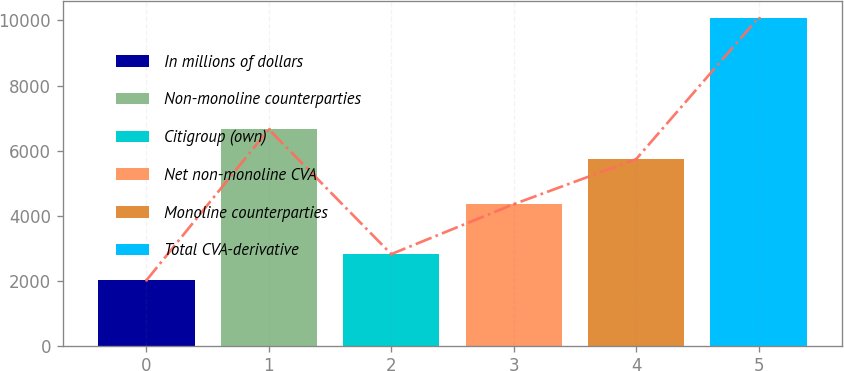Convert chart. <chart><loc_0><loc_0><loc_500><loc_500><bar_chart><fcel>In millions of dollars<fcel>Non-monoline counterparties<fcel>Citigroup (own)<fcel>Net non-monoline CVA<fcel>Monoline counterparties<fcel>Total CVA-derivative<nl><fcel>2008<fcel>6653<fcel>2815.8<fcel>4350<fcel>5736<fcel>10086<nl></chart> 